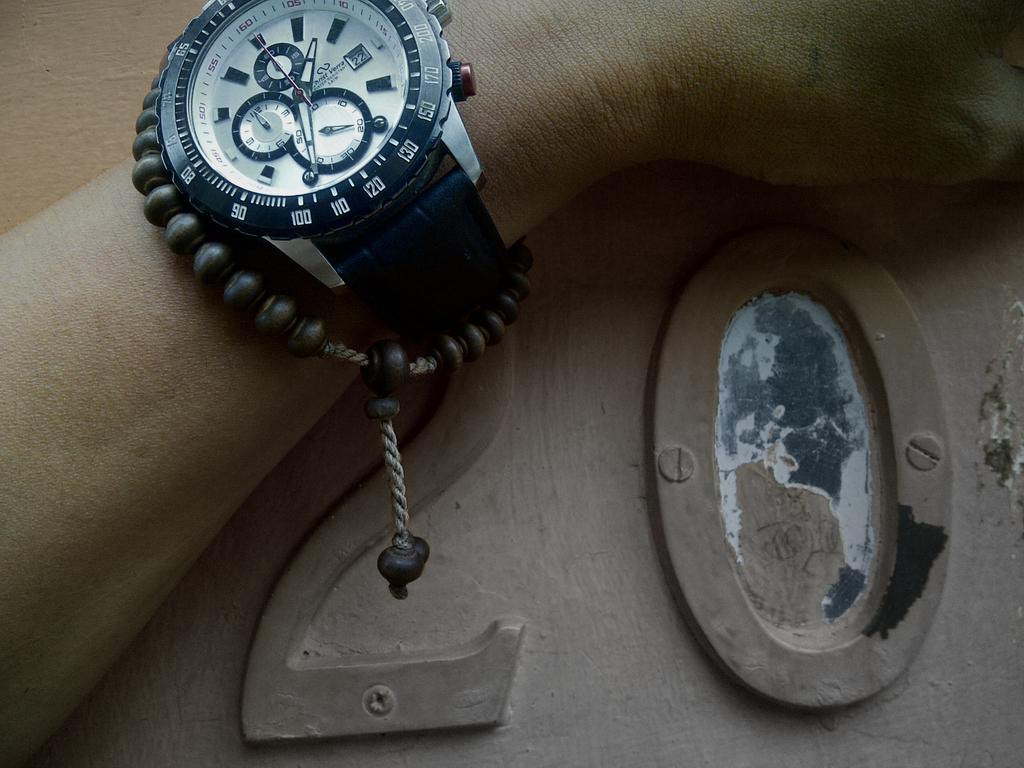<image>
Render a clear and concise summary of the photo. Man wearing a watch and resting his arm on a surface which has the number twenty written on it. 